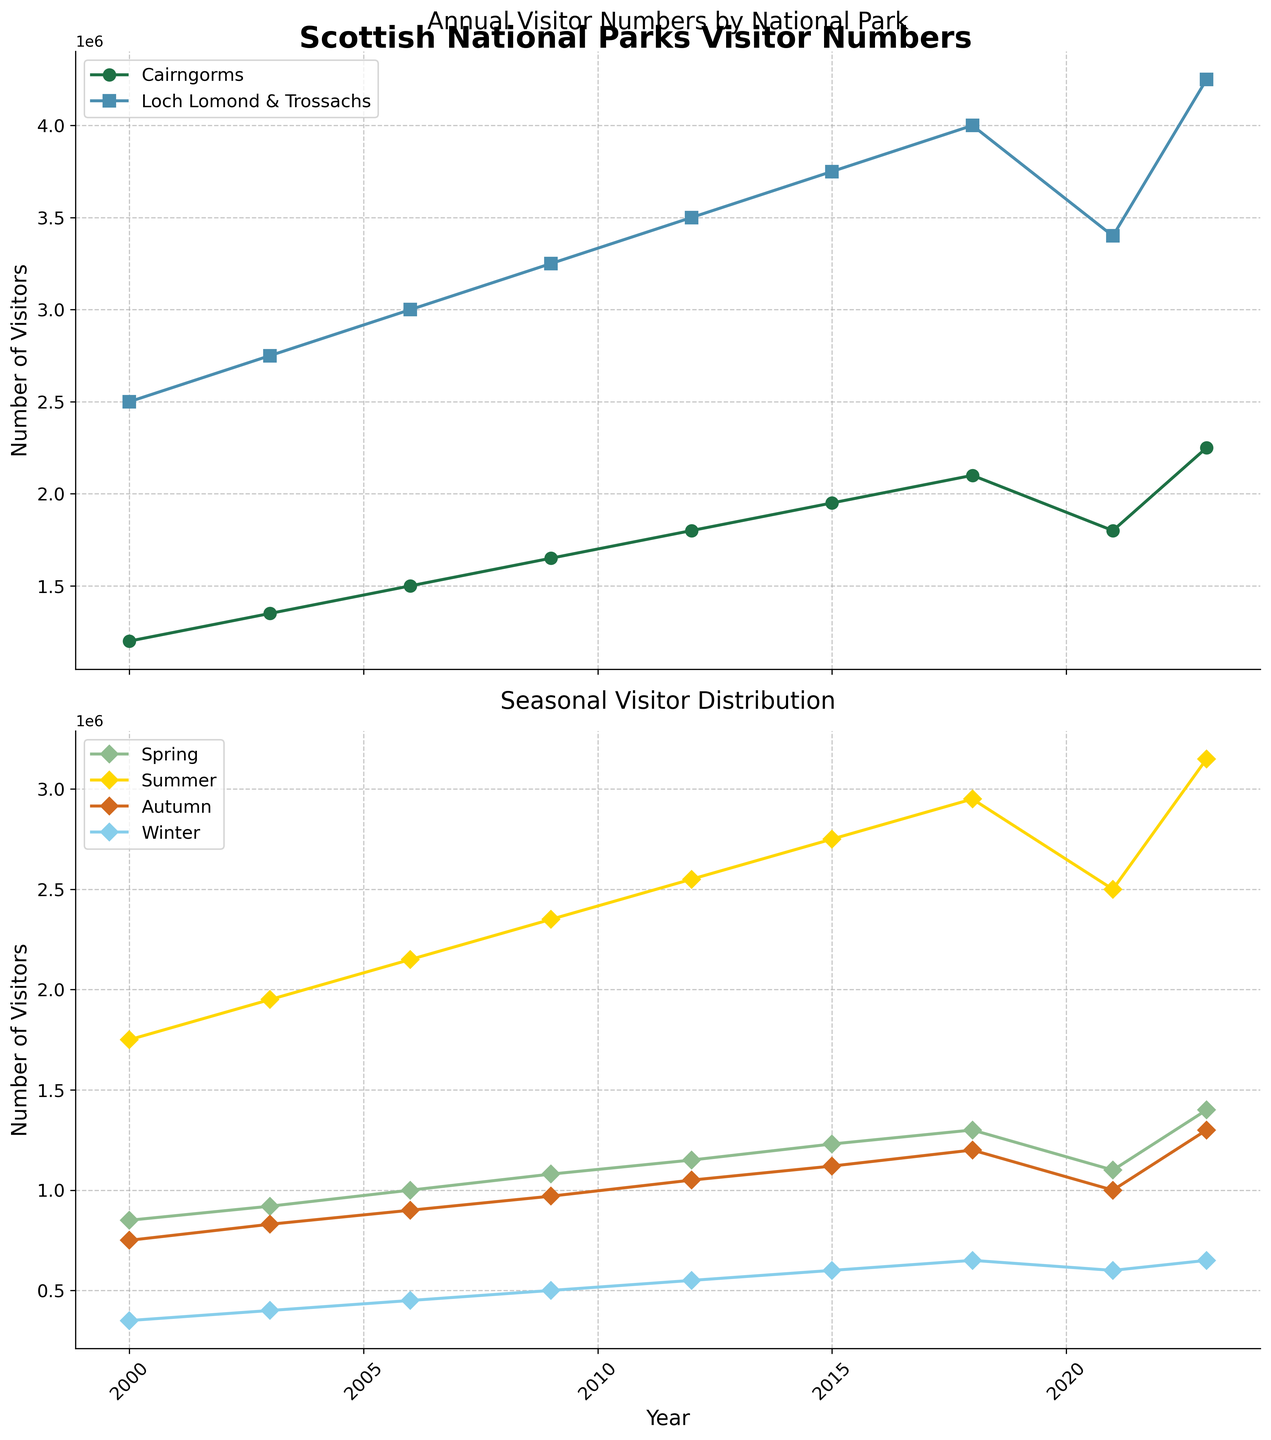How did visitor numbers in Cairngorms National Park change from 2000 to 2023? From the figure, follow the line representing Cairngorms National Park from 2000 to 2023. Observe the general trend of the visitor numbers increasing over the years.
Answer: Increased Which year had the highest number of visitors in Loch Lomond and The Trossachs National Park? Look for the highest point on the line representing Loch Lomond and The Trossachs National Park. The peak is reached in 2023.
Answer: 2023 During which season are visitor numbers the highest in 2018? Find the four seasonal data points for 2018 and see which one is the highest. Summer has the highest visitor number compared to Spring, Autumn, and Winter.
Answer: Summer Has there ever been a decline in visitor numbers in Cairngorms National Park? Examine the line representing Cairngorms National Park. The only notable decline is from 2018 to 2021.
Answer: Yes Compare the growth rate of visitors in Cairngorms versus Loch Lomond from 2000 to 2023. Which grew faster? Determine the initial and final visitor numbers for both parks and calculate the growth. Cairngorms grew from 1,200,000 to 2,250,000, while Loch Lomond grew from 2,500,000 to 4,250,000. Growing faster is Loch Lomond.
Answer: Loch Lomond How does the winter visitor number in 2021 compare to the autumn visitor number in the same year? Locate the visitor numbers for Winter and Autumn in 2021. Compare 600,000 (Winter) with 1,000,000 (Autumn).
Answer: Lower in Winter What is the average number of visitors in Spring from 2000 to 2023? Add up Spring visitor numbers across the years and divide by the number of years. The sum is 850,000+920,000+1,000,000+1,080,000+1,150,000+1,230,000+1,300,000+1,100,000+1,400,000 = 9,030,000; divided by 9 years = 1,003,333
Answer: 1,003,333 In which year did Summer see its largest increase in visitors compared to the previous year? Review the Summer visitor numbers for each year and calculate the differences from the previous year. The most significant increase is between 2021 (2,500,000) and 2023 (3,150,000).
Answer: 2023 Did Autumn visitor numbers increase or decrease from 2009 to 2012? Compare the Autumn visitor numbers for 2009 (970,000) and 2012 (1,050,000).
Answer: Increased 